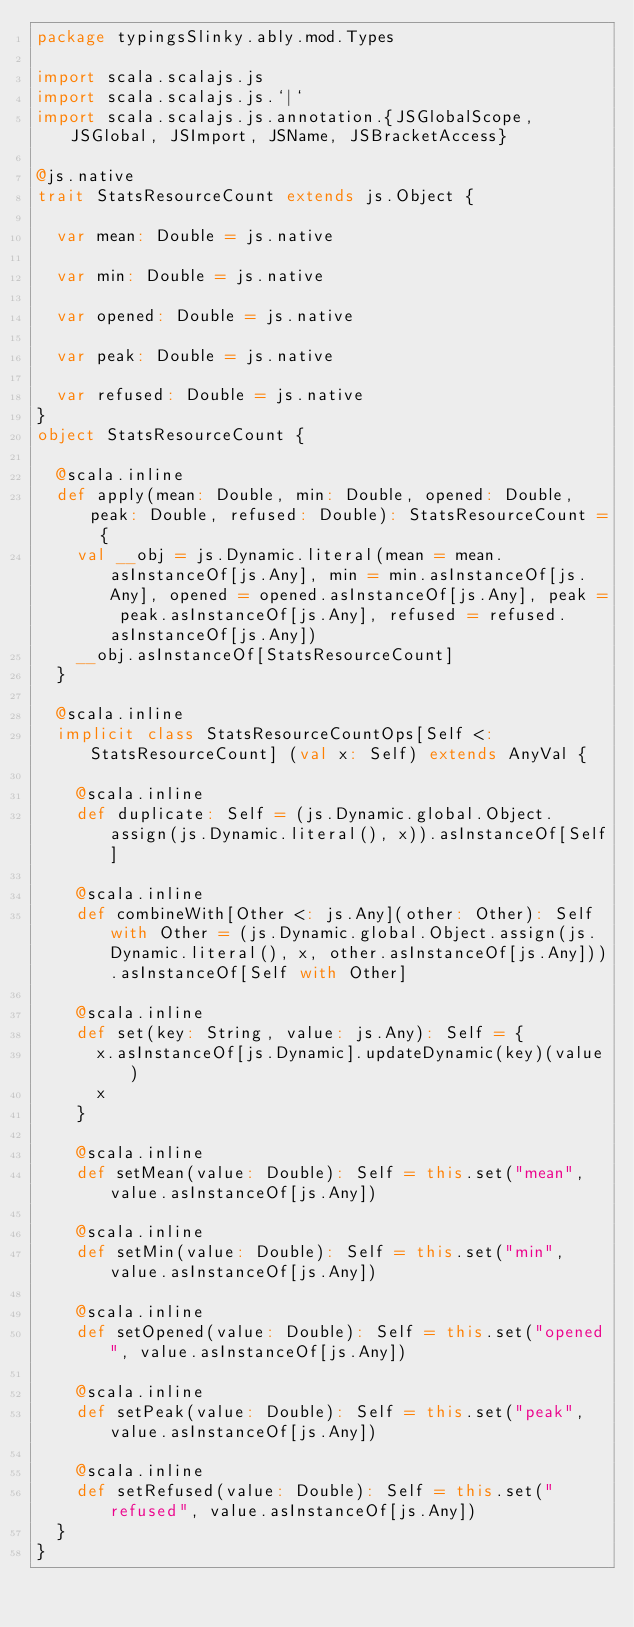<code> <loc_0><loc_0><loc_500><loc_500><_Scala_>package typingsSlinky.ably.mod.Types

import scala.scalajs.js
import scala.scalajs.js.`|`
import scala.scalajs.js.annotation.{JSGlobalScope, JSGlobal, JSImport, JSName, JSBracketAccess}

@js.native
trait StatsResourceCount extends js.Object {
  
  var mean: Double = js.native
  
  var min: Double = js.native
  
  var opened: Double = js.native
  
  var peak: Double = js.native
  
  var refused: Double = js.native
}
object StatsResourceCount {
  
  @scala.inline
  def apply(mean: Double, min: Double, opened: Double, peak: Double, refused: Double): StatsResourceCount = {
    val __obj = js.Dynamic.literal(mean = mean.asInstanceOf[js.Any], min = min.asInstanceOf[js.Any], opened = opened.asInstanceOf[js.Any], peak = peak.asInstanceOf[js.Any], refused = refused.asInstanceOf[js.Any])
    __obj.asInstanceOf[StatsResourceCount]
  }
  
  @scala.inline
  implicit class StatsResourceCountOps[Self <: StatsResourceCount] (val x: Self) extends AnyVal {
    
    @scala.inline
    def duplicate: Self = (js.Dynamic.global.Object.assign(js.Dynamic.literal(), x)).asInstanceOf[Self]
    
    @scala.inline
    def combineWith[Other <: js.Any](other: Other): Self with Other = (js.Dynamic.global.Object.assign(js.Dynamic.literal(), x, other.asInstanceOf[js.Any])).asInstanceOf[Self with Other]
    
    @scala.inline
    def set(key: String, value: js.Any): Self = {
      x.asInstanceOf[js.Dynamic].updateDynamic(key)(value)
      x
    }
    
    @scala.inline
    def setMean(value: Double): Self = this.set("mean", value.asInstanceOf[js.Any])
    
    @scala.inline
    def setMin(value: Double): Self = this.set("min", value.asInstanceOf[js.Any])
    
    @scala.inline
    def setOpened(value: Double): Self = this.set("opened", value.asInstanceOf[js.Any])
    
    @scala.inline
    def setPeak(value: Double): Self = this.set("peak", value.asInstanceOf[js.Any])
    
    @scala.inline
    def setRefused(value: Double): Self = this.set("refused", value.asInstanceOf[js.Any])
  }
}
</code> 